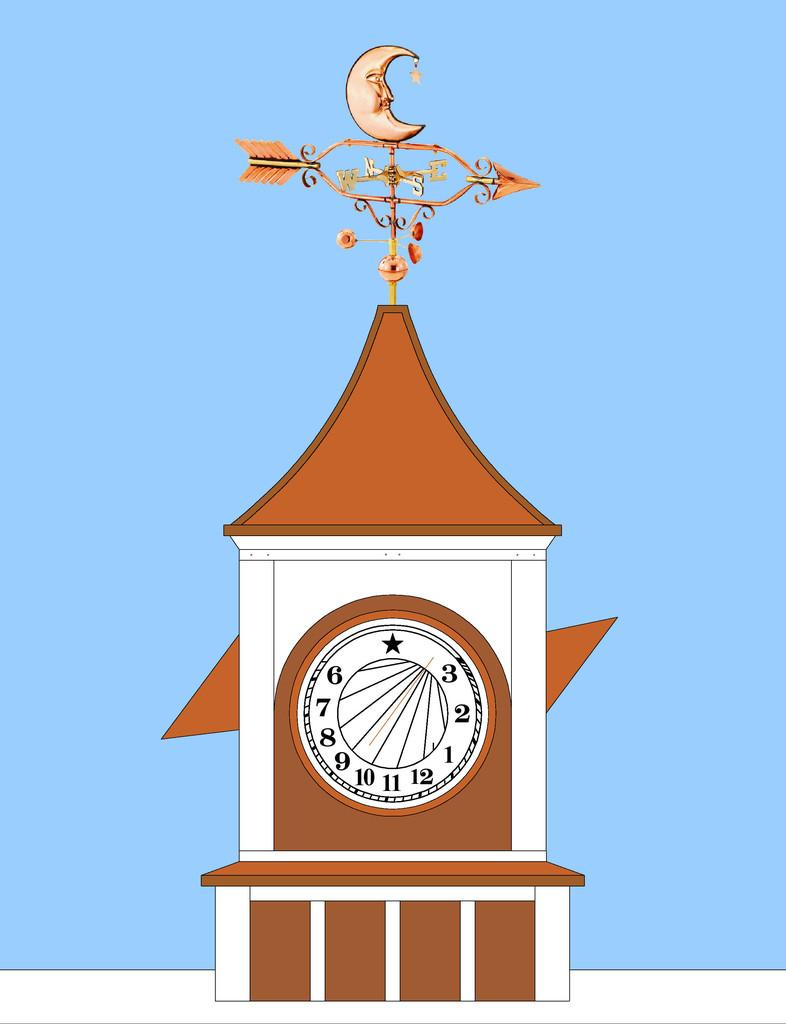<image>
Write a terse but informative summary of the picture. an area that has the letters 6 and 3 on it 